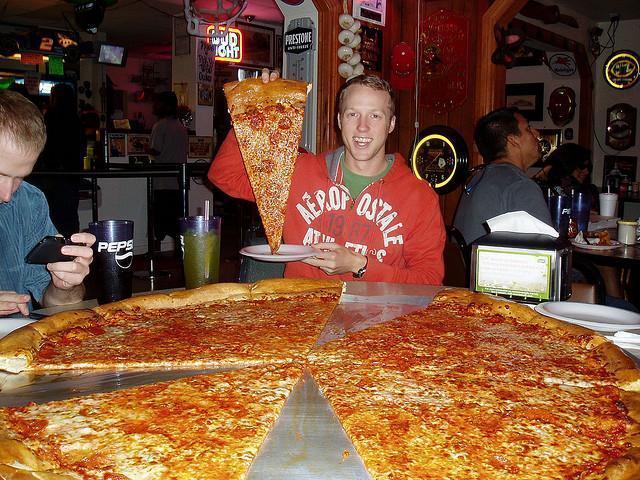How many cups are there?
Give a very brief answer. 2. How many pizzas are there?
Give a very brief answer. 4. How many people are visible?
Give a very brief answer. 6. How many chairs can be seen?
Give a very brief answer. 2. 